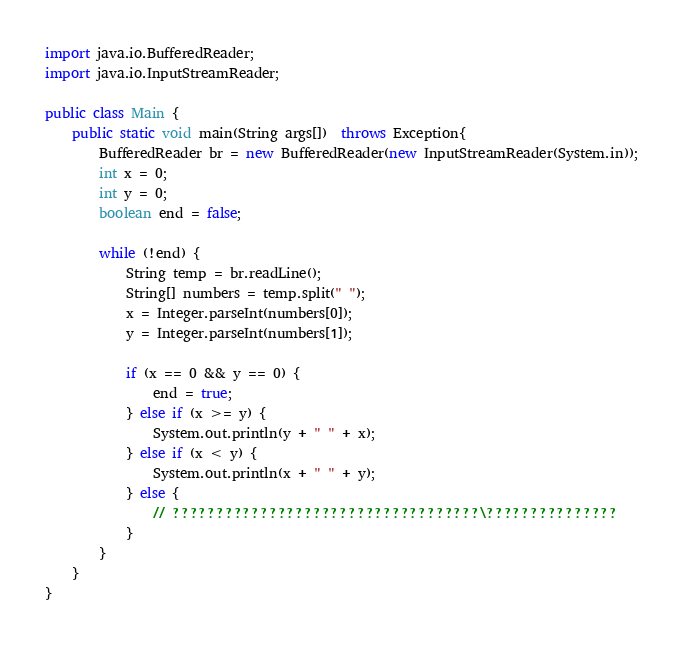<code> <loc_0><loc_0><loc_500><loc_500><_Java_>
import java.io.BufferedReader;
import java.io.InputStreamReader;

public class Main {
	public static void main(String args[])  throws Exception{
		BufferedReader br = new BufferedReader(new InputStreamReader(System.in));
		int x = 0;
		int y = 0;
		boolean end = false;

		while (!end) {
			String temp = br.readLine();
			String[] numbers = temp.split(" ");
			x = Integer.parseInt(numbers[0]);
			y = Integer.parseInt(numbers[1]);

			if (x == 0 && y == 0) {
				end = true;
			} else if (x >= y) {
				System.out.println(y + " " + x);
			} else if (x < y) {
				System.out.println(x + " " + y);
			} else {
				// ???????????????????????????????????\???????????????
			}
		}
	}
}</code> 